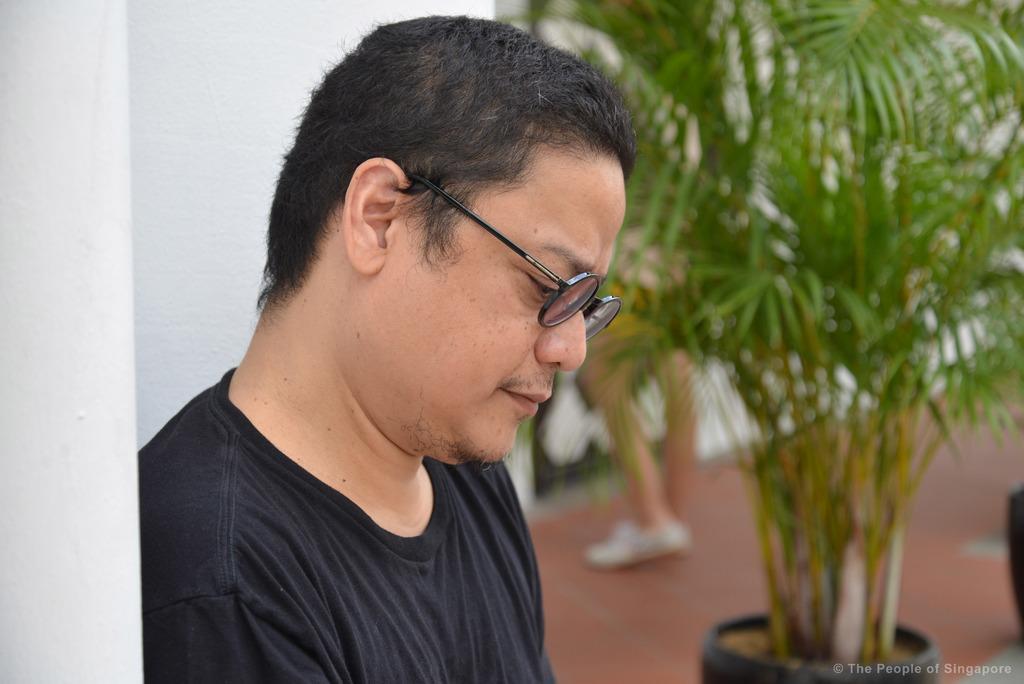Could you give a brief overview of what you see in this image? In this image beside the plain white wall there is a person wearing glasses and a black t shirt. In the background there is a plant and also some person on the floor. There is a logo in the bottom right corner. 